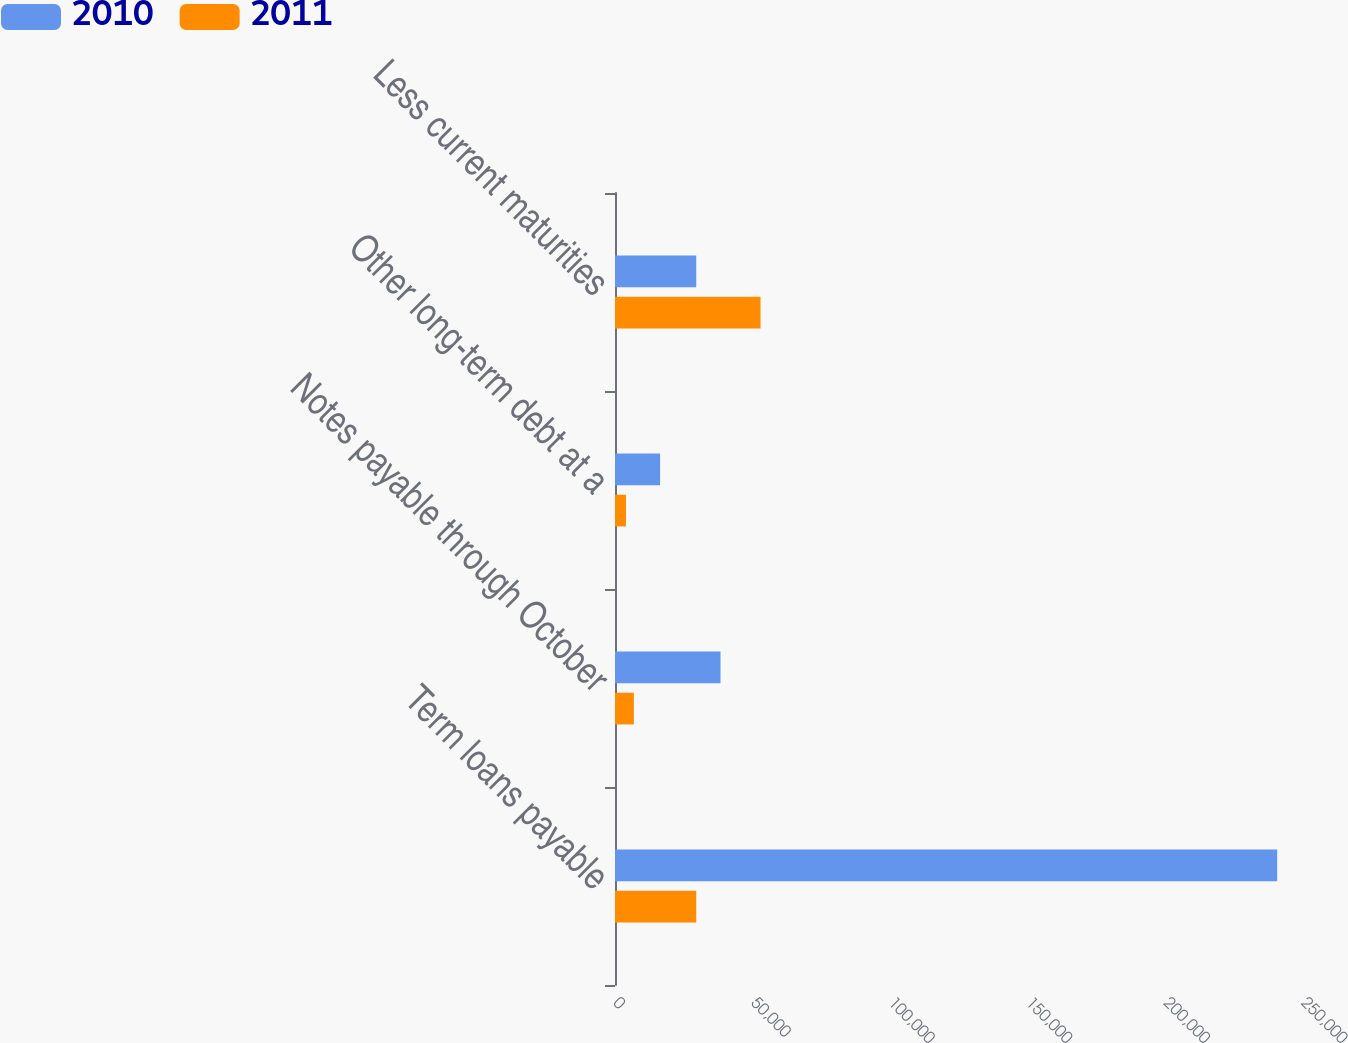Convert chart. <chart><loc_0><loc_0><loc_500><loc_500><stacked_bar_chart><ecel><fcel>Term loans payable<fcel>Notes payable through October<fcel>Other long-term debt at a<fcel>Less current maturities<nl><fcel>2010<fcel>240625<fcel>38338<fcel>16383<fcel>29524<nl><fcel>2011<fcel>29524<fcel>6869<fcel>3986<fcel>52888<nl></chart> 